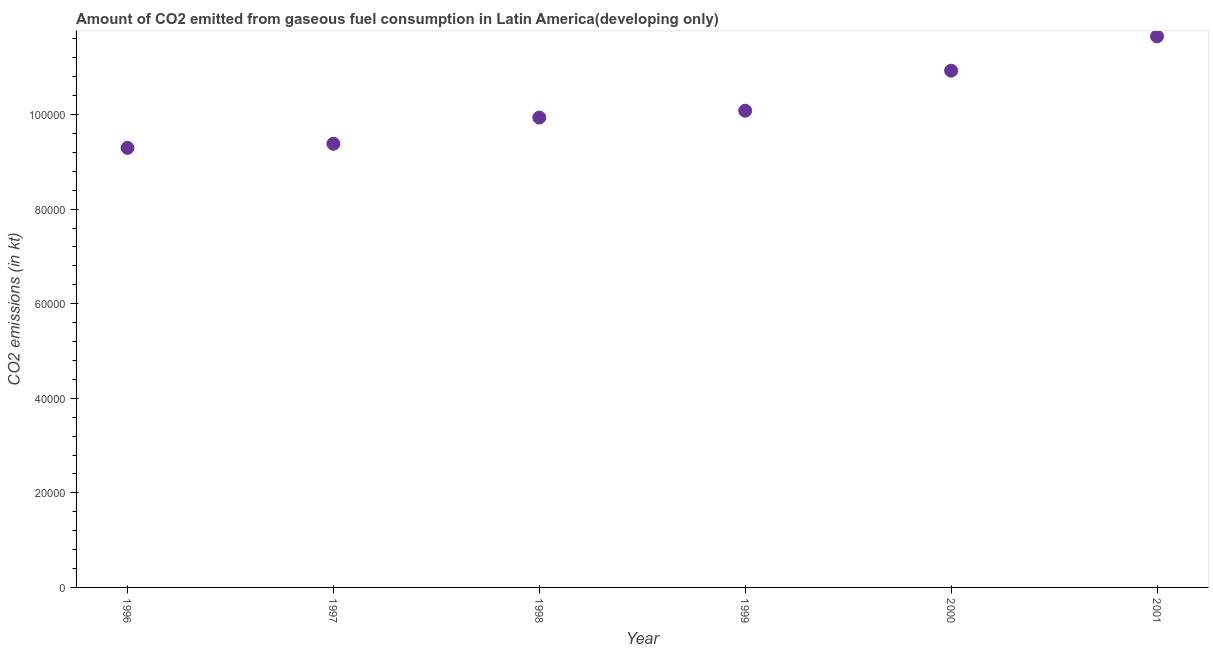What is the co2 emissions from gaseous fuel consumption in 1997?
Provide a succinct answer. 9.38e+04. Across all years, what is the maximum co2 emissions from gaseous fuel consumption?
Offer a very short reply. 1.17e+05. Across all years, what is the minimum co2 emissions from gaseous fuel consumption?
Your answer should be compact. 9.29e+04. In which year was the co2 emissions from gaseous fuel consumption minimum?
Make the answer very short. 1996. What is the sum of the co2 emissions from gaseous fuel consumption?
Your response must be concise. 6.13e+05. What is the difference between the co2 emissions from gaseous fuel consumption in 1998 and 1999?
Provide a short and direct response. -1437.78. What is the average co2 emissions from gaseous fuel consumption per year?
Your answer should be compact. 1.02e+05. What is the median co2 emissions from gaseous fuel consumption?
Make the answer very short. 1.00e+05. In how many years, is the co2 emissions from gaseous fuel consumption greater than 32000 kt?
Your response must be concise. 6. What is the ratio of the co2 emissions from gaseous fuel consumption in 1997 to that in 2000?
Provide a succinct answer. 0.86. Is the co2 emissions from gaseous fuel consumption in 1999 less than that in 2001?
Provide a succinct answer. Yes. What is the difference between the highest and the second highest co2 emissions from gaseous fuel consumption?
Your response must be concise. 7247.67. Is the sum of the co2 emissions from gaseous fuel consumption in 1996 and 2001 greater than the maximum co2 emissions from gaseous fuel consumption across all years?
Your answer should be compact. Yes. What is the difference between the highest and the lowest co2 emissions from gaseous fuel consumption?
Ensure brevity in your answer.  2.36e+04. How many dotlines are there?
Give a very brief answer. 1. How many years are there in the graph?
Provide a succinct answer. 6. What is the difference between two consecutive major ticks on the Y-axis?
Your answer should be compact. 2.00e+04. Does the graph contain any zero values?
Offer a terse response. No. What is the title of the graph?
Your response must be concise. Amount of CO2 emitted from gaseous fuel consumption in Latin America(developing only). What is the label or title of the Y-axis?
Keep it short and to the point. CO2 emissions (in kt). What is the CO2 emissions (in kt) in 1996?
Make the answer very short. 9.29e+04. What is the CO2 emissions (in kt) in 1997?
Keep it short and to the point. 9.38e+04. What is the CO2 emissions (in kt) in 1998?
Offer a terse response. 9.94e+04. What is the CO2 emissions (in kt) in 1999?
Offer a very short reply. 1.01e+05. What is the CO2 emissions (in kt) in 2000?
Make the answer very short. 1.09e+05. What is the CO2 emissions (in kt) in 2001?
Your answer should be compact. 1.17e+05. What is the difference between the CO2 emissions (in kt) in 1996 and 1997?
Make the answer very short. -872.25. What is the difference between the CO2 emissions (in kt) in 1996 and 1998?
Your answer should be very brief. -6419.66. What is the difference between the CO2 emissions (in kt) in 1996 and 1999?
Your answer should be very brief. -7857.45. What is the difference between the CO2 emissions (in kt) in 1996 and 2000?
Your answer should be compact. -1.63e+04. What is the difference between the CO2 emissions (in kt) in 1996 and 2001?
Your answer should be very brief. -2.36e+04. What is the difference between the CO2 emissions (in kt) in 1997 and 1998?
Provide a succinct answer. -5547.41. What is the difference between the CO2 emissions (in kt) in 1997 and 1999?
Offer a terse response. -6985.19. What is the difference between the CO2 emissions (in kt) in 1997 and 2000?
Your response must be concise. -1.55e+04. What is the difference between the CO2 emissions (in kt) in 1997 and 2001?
Offer a very short reply. -2.27e+04. What is the difference between the CO2 emissions (in kt) in 1998 and 1999?
Your response must be concise. -1437.78. What is the difference between the CO2 emissions (in kt) in 1998 and 2000?
Make the answer very short. -9907.77. What is the difference between the CO2 emissions (in kt) in 1998 and 2001?
Your response must be concise. -1.72e+04. What is the difference between the CO2 emissions (in kt) in 1999 and 2000?
Keep it short and to the point. -8469.99. What is the difference between the CO2 emissions (in kt) in 1999 and 2001?
Offer a terse response. -1.57e+04. What is the difference between the CO2 emissions (in kt) in 2000 and 2001?
Provide a short and direct response. -7247.67. What is the ratio of the CO2 emissions (in kt) in 1996 to that in 1997?
Provide a short and direct response. 0.99. What is the ratio of the CO2 emissions (in kt) in 1996 to that in 1998?
Your answer should be compact. 0.94. What is the ratio of the CO2 emissions (in kt) in 1996 to that in 1999?
Keep it short and to the point. 0.92. What is the ratio of the CO2 emissions (in kt) in 1996 to that in 2000?
Your answer should be compact. 0.85. What is the ratio of the CO2 emissions (in kt) in 1996 to that in 2001?
Your response must be concise. 0.8. What is the ratio of the CO2 emissions (in kt) in 1997 to that in 1998?
Ensure brevity in your answer.  0.94. What is the ratio of the CO2 emissions (in kt) in 1997 to that in 2000?
Offer a very short reply. 0.86. What is the ratio of the CO2 emissions (in kt) in 1997 to that in 2001?
Keep it short and to the point. 0.81. What is the ratio of the CO2 emissions (in kt) in 1998 to that in 1999?
Ensure brevity in your answer.  0.99. What is the ratio of the CO2 emissions (in kt) in 1998 to that in 2000?
Your answer should be compact. 0.91. What is the ratio of the CO2 emissions (in kt) in 1998 to that in 2001?
Make the answer very short. 0.85. What is the ratio of the CO2 emissions (in kt) in 1999 to that in 2000?
Keep it short and to the point. 0.92. What is the ratio of the CO2 emissions (in kt) in 1999 to that in 2001?
Your response must be concise. 0.86. What is the ratio of the CO2 emissions (in kt) in 2000 to that in 2001?
Your answer should be compact. 0.94. 